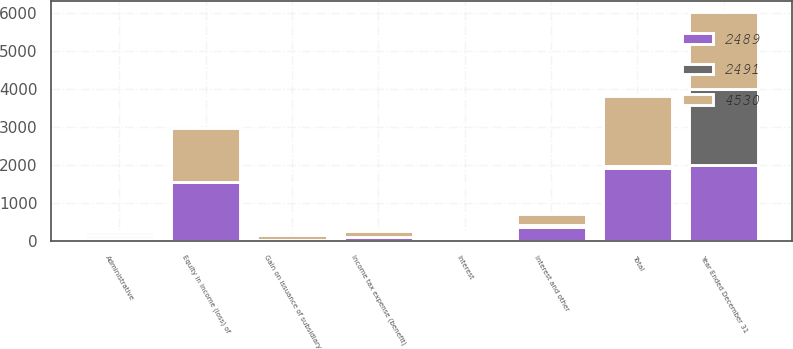Convert chart to OTSL. <chart><loc_0><loc_0><loc_500><loc_500><stacked_bar_chart><ecel><fcel>Year Ended December 31<fcel>Equity in income (loss) of<fcel>Gain on issuance of subsidiary<fcel>Interest and other<fcel>Total<fcel>Administrative<fcel>Interest<fcel>Income tax expense (benefit)<nl><fcel>2491<fcel>2008<fcel>12<fcel>2<fcel>42<fcel>52<fcel>82<fcel>56<fcel>8<nl><fcel>4530<fcel>2007<fcel>1425<fcel>141<fcel>293<fcel>1862<fcel>81<fcel>55<fcel>139<nl><fcel>2489<fcel>2006<fcel>1540<fcel>9<fcel>366<fcel>1916<fcel>61<fcel>75<fcel>104<nl></chart> 